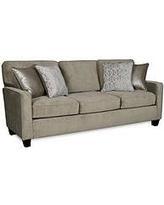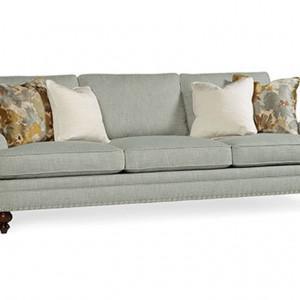The first image is the image on the left, the second image is the image on the right. For the images displayed, is the sentence "There are a total of 8 throw pillows." factually correct? Answer yes or no. Yes. The first image is the image on the left, the second image is the image on the right. Considering the images on both sides, is "One of the images shows a sectional sofa with an attached ottoman." valid? Answer yes or no. No. 